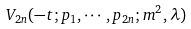<formula> <loc_0><loc_0><loc_500><loc_500>\ V _ { 2 n } ( - t ; p _ { 1 } , \cdots , p _ { 2 n } ; m ^ { 2 } , \lambda )</formula> 